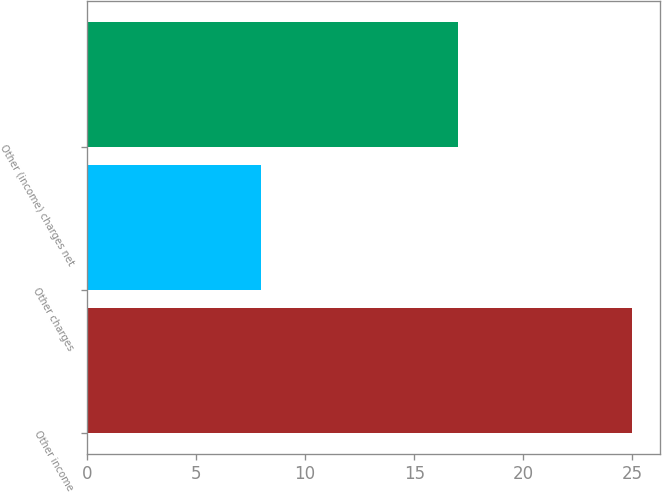Convert chart. <chart><loc_0><loc_0><loc_500><loc_500><bar_chart><fcel>Other income<fcel>Other charges<fcel>Other (income) charges net<nl><fcel>25<fcel>8<fcel>17<nl></chart> 